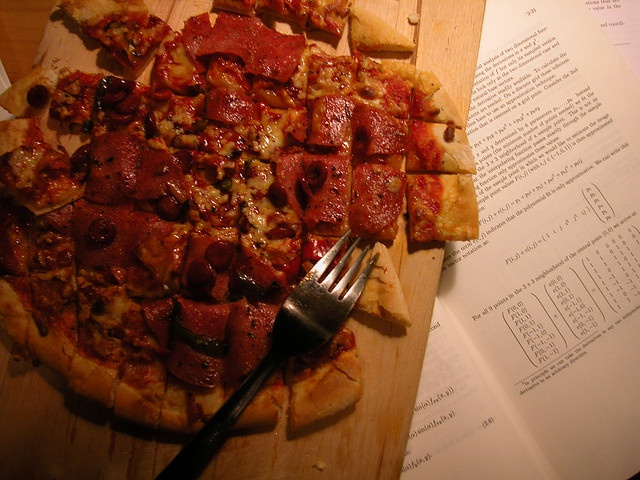Describe the objects in this image and their specific colors. I can see pizza in maroon, black, and brown tones and fork in maroon, black, and gray tones in this image. 